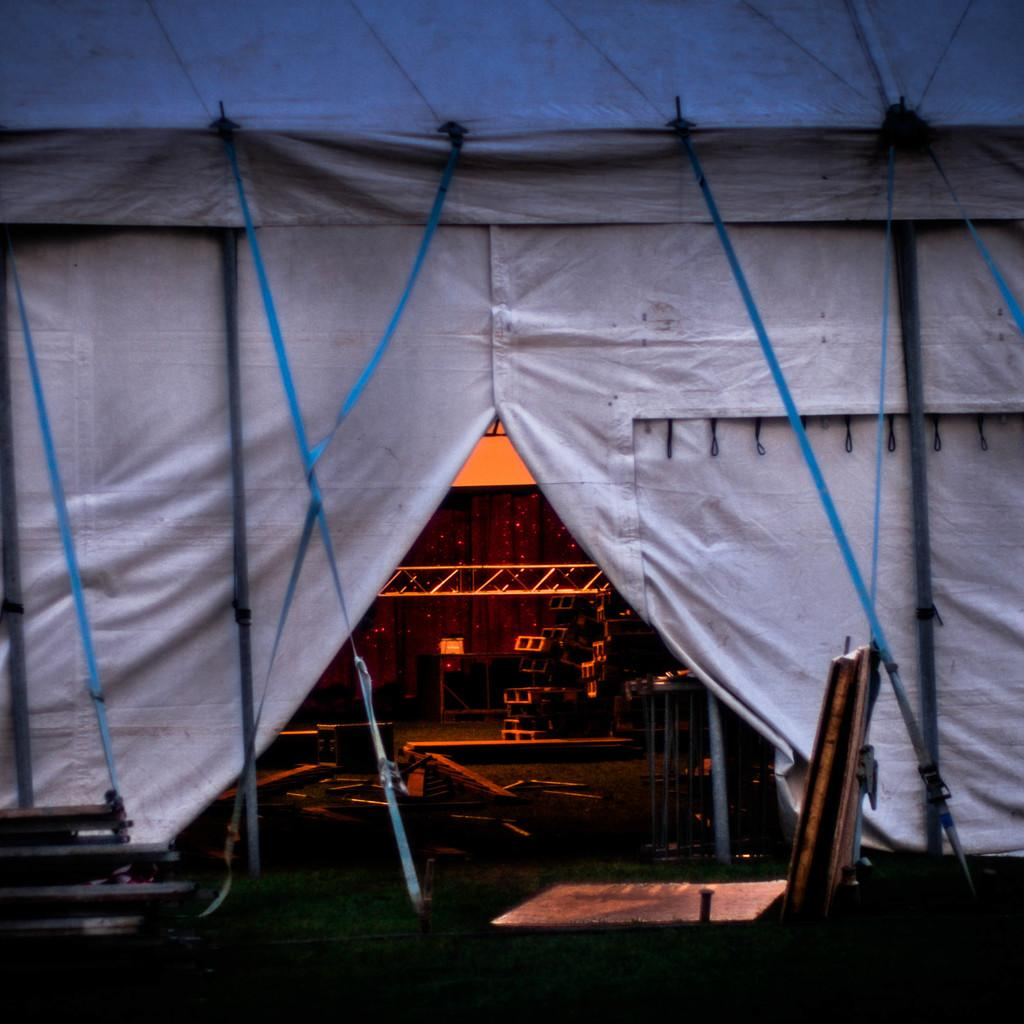What structure can be seen in the image? There is a tent in the image. What is inside the tent? There are objects inside the tent. Where are the objects located within the tent? The objects are on the floor. What can be seen on the ground outside the tent? There are objects on the grassland at the bottom of the image. What type of agreement was reached between the grass and the objects in the image? There is no agreement between the grass and the objects in the image, as they are inanimate objects and cannot engage in agreements. 